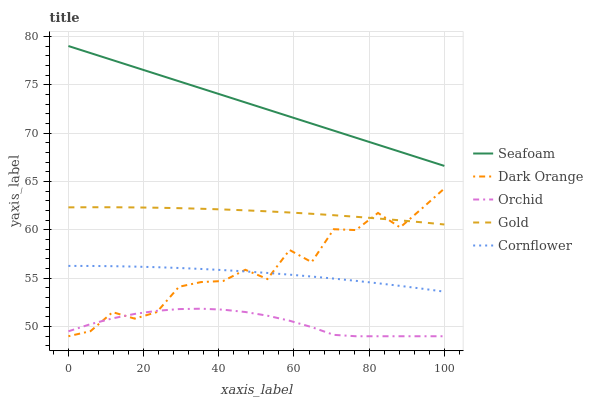Does Orchid have the minimum area under the curve?
Answer yes or no. Yes. Does Seafoam have the maximum area under the curve?
Answer yes or no. Yes. Does Cornflower have the minimum area under the curve?
Answer yes or no. No. Does Cornflower have the maximum area under the curve?
Answer yes or no. No. Is Seafoam the smoothest?
Answer yes or no. Yes. Is Dark Orange the roughest?
Answer yes or no. Yes. Is Cornflower the smoothest?
Answer yes or no. No. Is Cornflower the roughest?
Answer yes or no. No. Does Dark Orange have the lowest value?
Answer yes or no. Yes. Does Cornflower have the lowest value?
Answer yes or no. No. Does Seafoam have the highest value?
Answer yes or no. Yes. Does Cornflower have the highest value?
Answer yes or no. No. Is Orchid less than Cornflower?
Answer yes or no. Yes. Is Cornflower greater than Orchid?
Answer yes or no. Yes. Does Orchid intersect Dark Orange?
Answer yes or no. Yes. Is Orchid less than Dark Orange?
Answer yes or no. No. Is Orchid greater than Dark Orange?
Answer yes or no. No. Does Orchid intersect Cornflower?
Answer yes or no. No. 